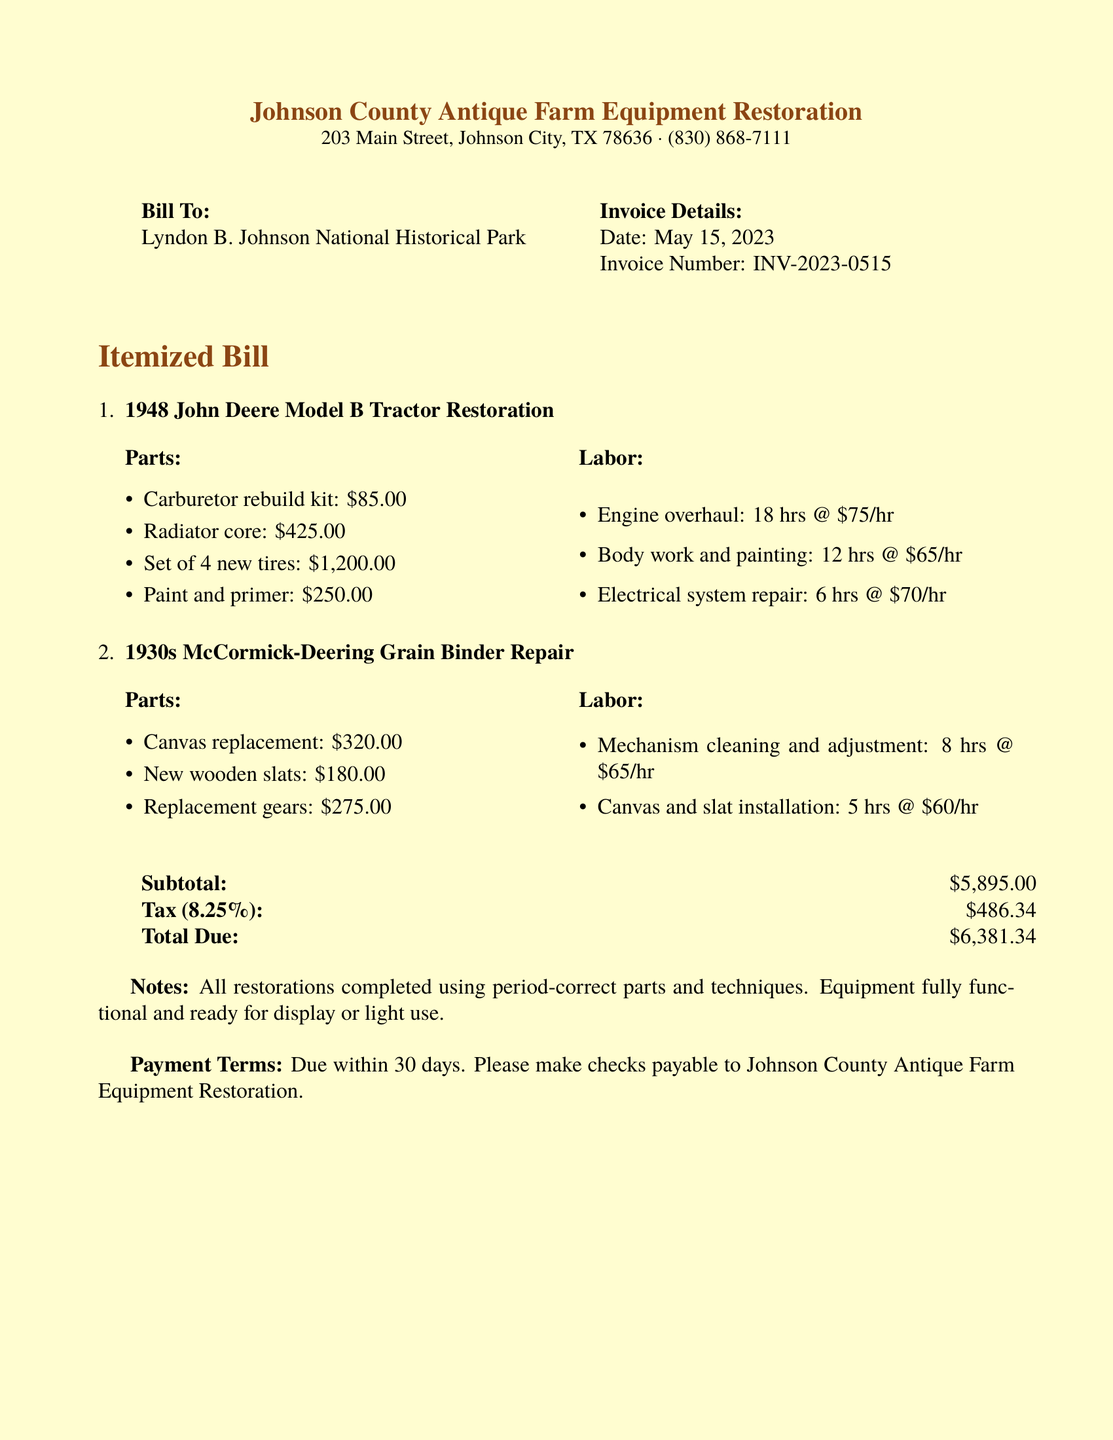What is the date of the invoice? The date of the invoice is specified in the document as May 15, 2023.
Answer: May 15, 2023 What is the total amount due? The total amount due is the final amount that needs to be paid as indicated in the document.
Answer: $6,381.34 How many hours were spent on the engine overhaul? The document lists that the engine overhaul took 18 hours to complete.
Answer: 18 hrs What is the subtotal amount before tax? The subtotal is given as the sum of parts and labor before tax is applied.
Answer: $5,895.00 What type of tractor is being restored? The type of tractor mentioned in the document is a John Deere Model B.
Answer: John Deere Model B How many new tires were purchased for the tractor? The document specifies that a set of 4 new tires was purchased for the restoration.
Answer: 4 What is the tax percentage applied in the bill? The tax percentage applied to the bill is indicated as 8.25%.
Answer: 8.25% What is the total number of hours spent on the McCormick-Deering Grain Binder repair? The total hours for the McCormick-Deering Grain Binder repair is the sum of all labor hours listed for this item.
Answer: 13 hrs What are the payment terms specified in the document? The payment terms mention when the payment is due and how it should be made.
Answer: Due within 30 days 